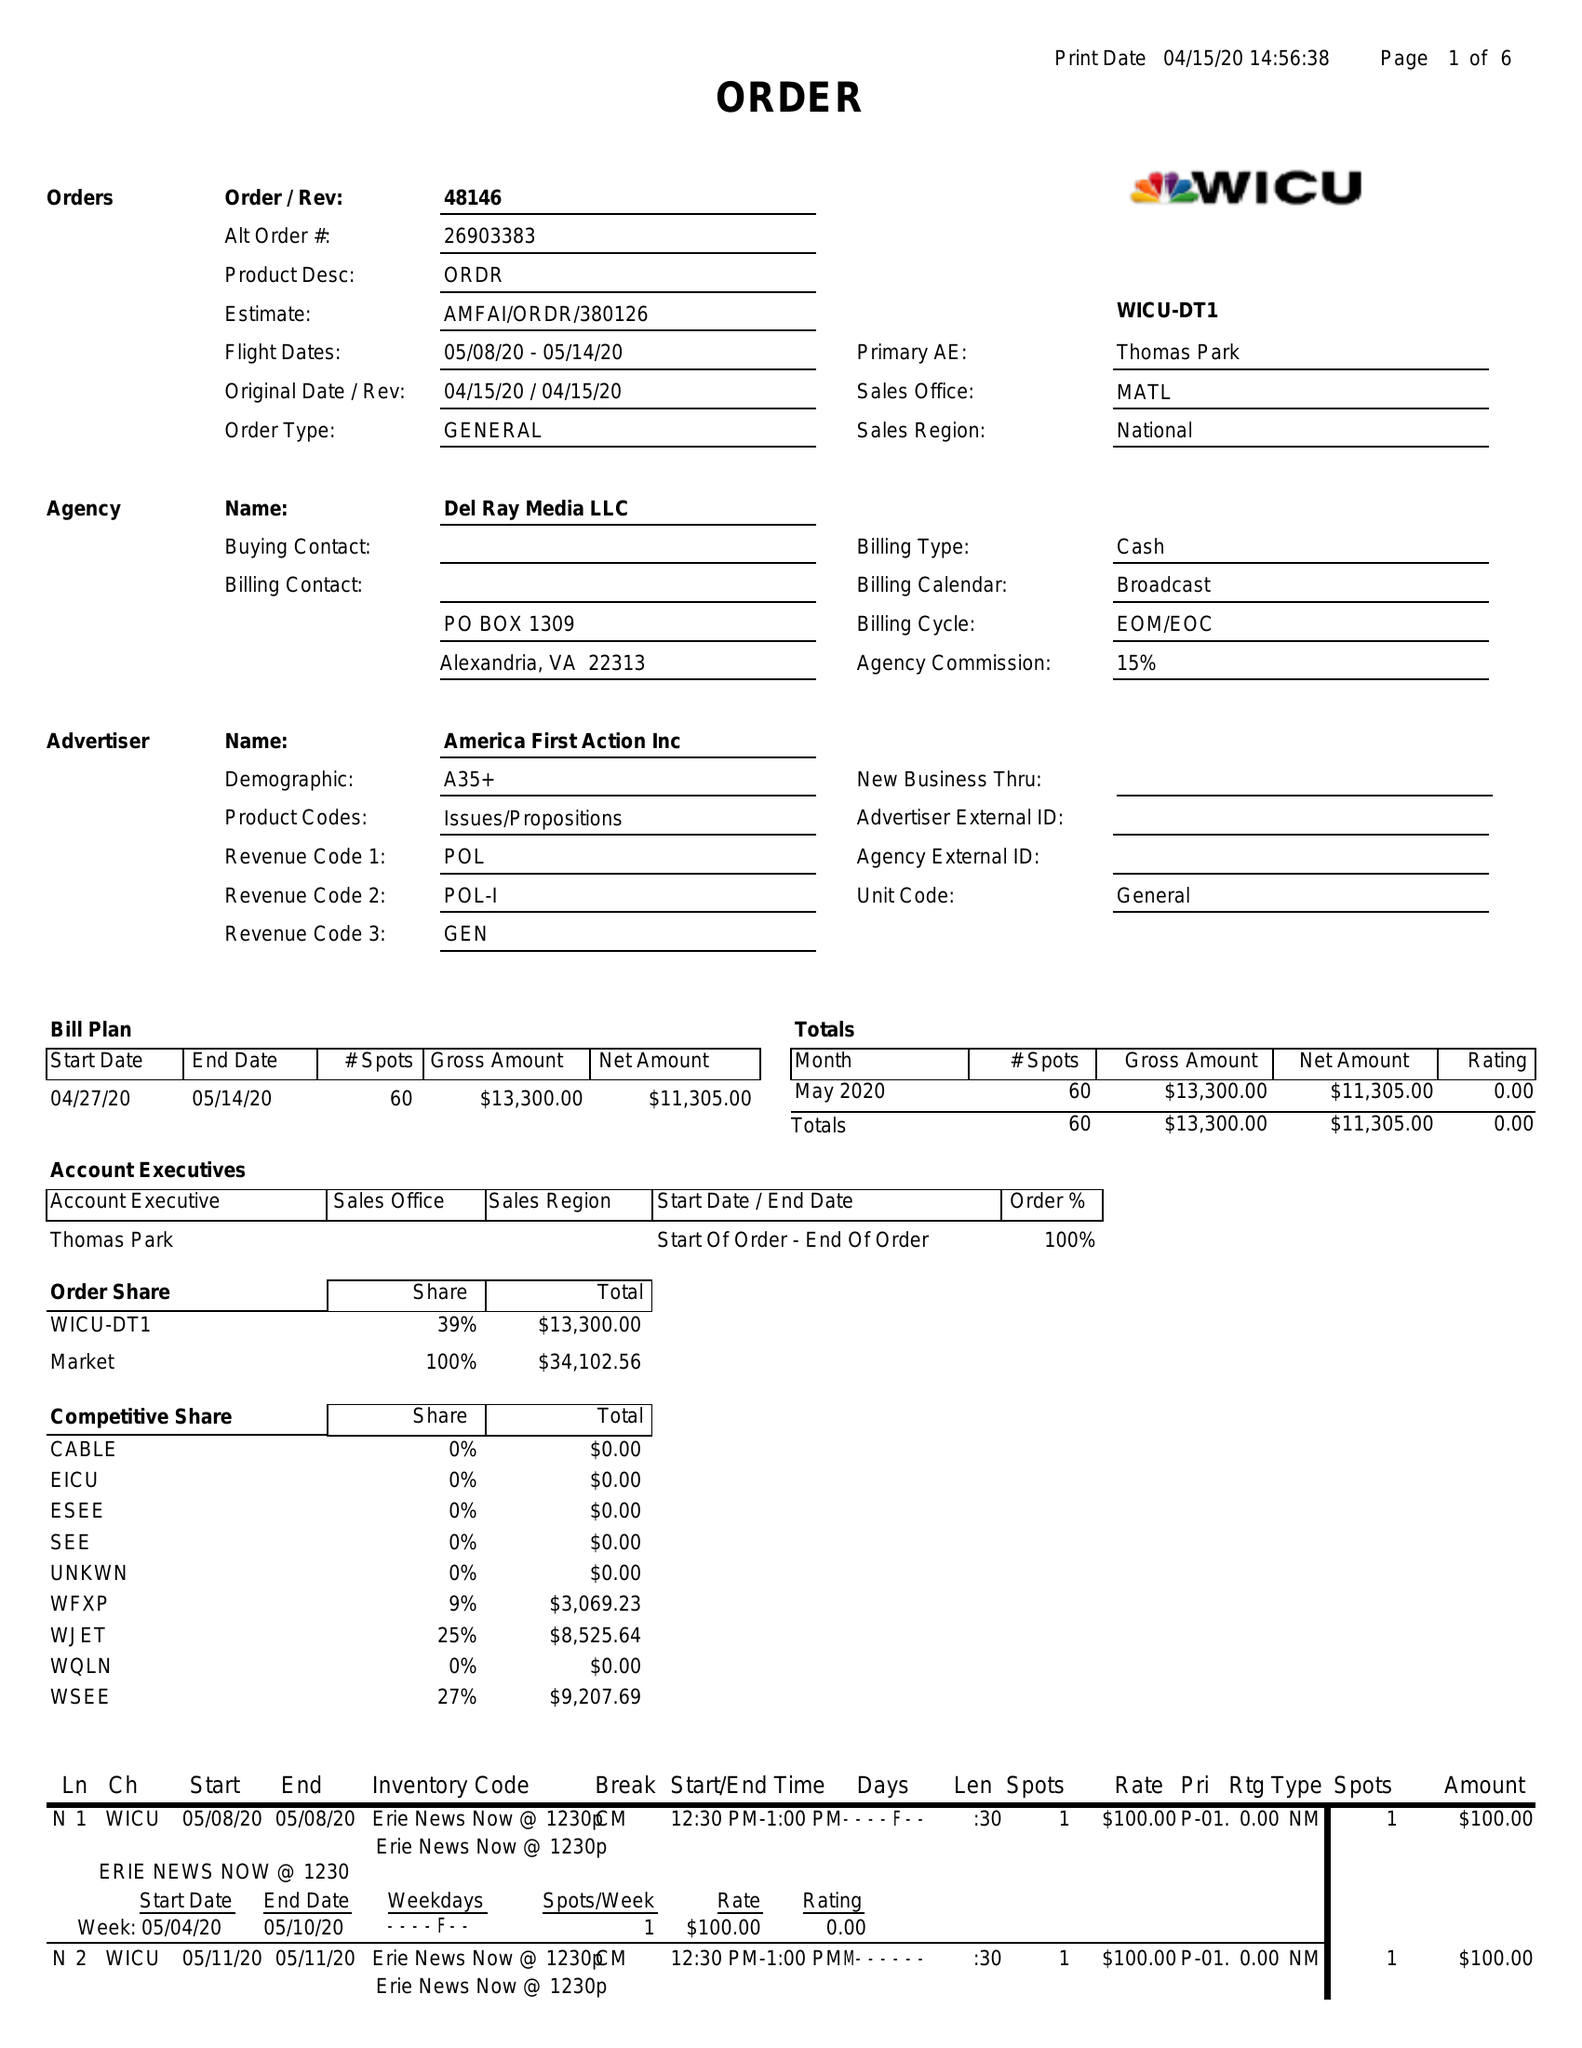What is the value for the flight_from?
Answer the question using a single word or phrase. 05/08/20 